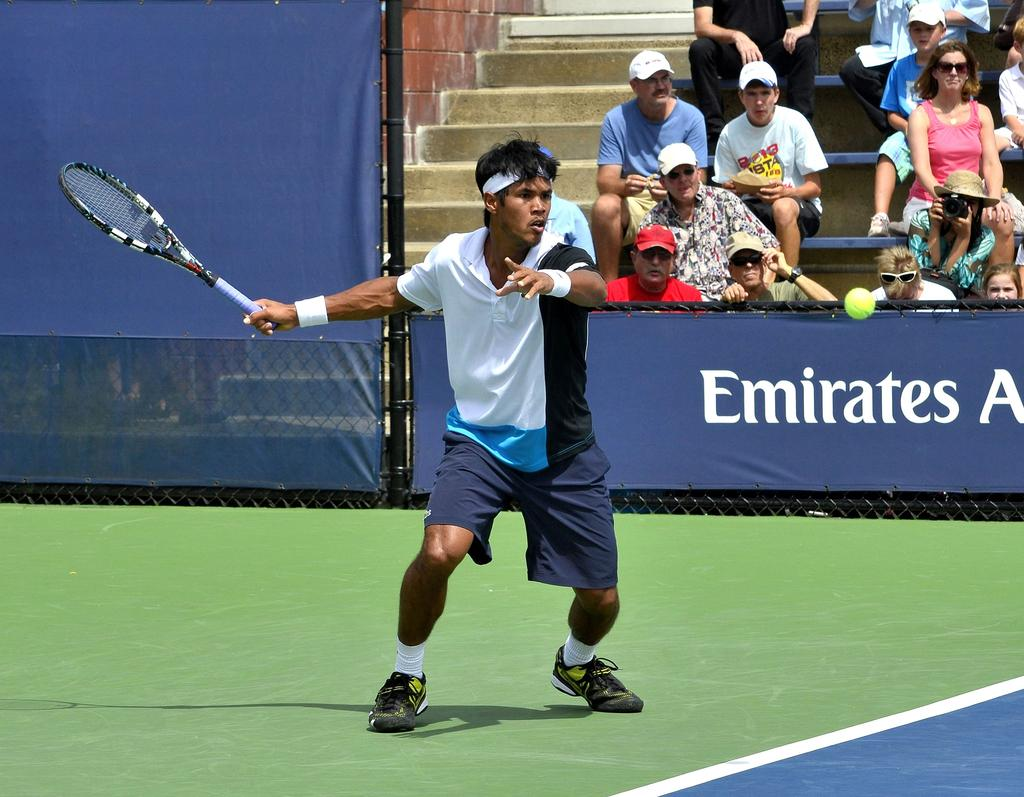Who is the main subject in the image? There is a man in the image. What is the man holding in the image? The man is holding a tennis racket. Are there any other people in the image? Yes, there are people in the image. What are the people doing in the image? The people are looking at the man with the tennis racket. What type of bell can be heard ringing in the image? There is no bell present in the image, and therefore no sound can be heard. 